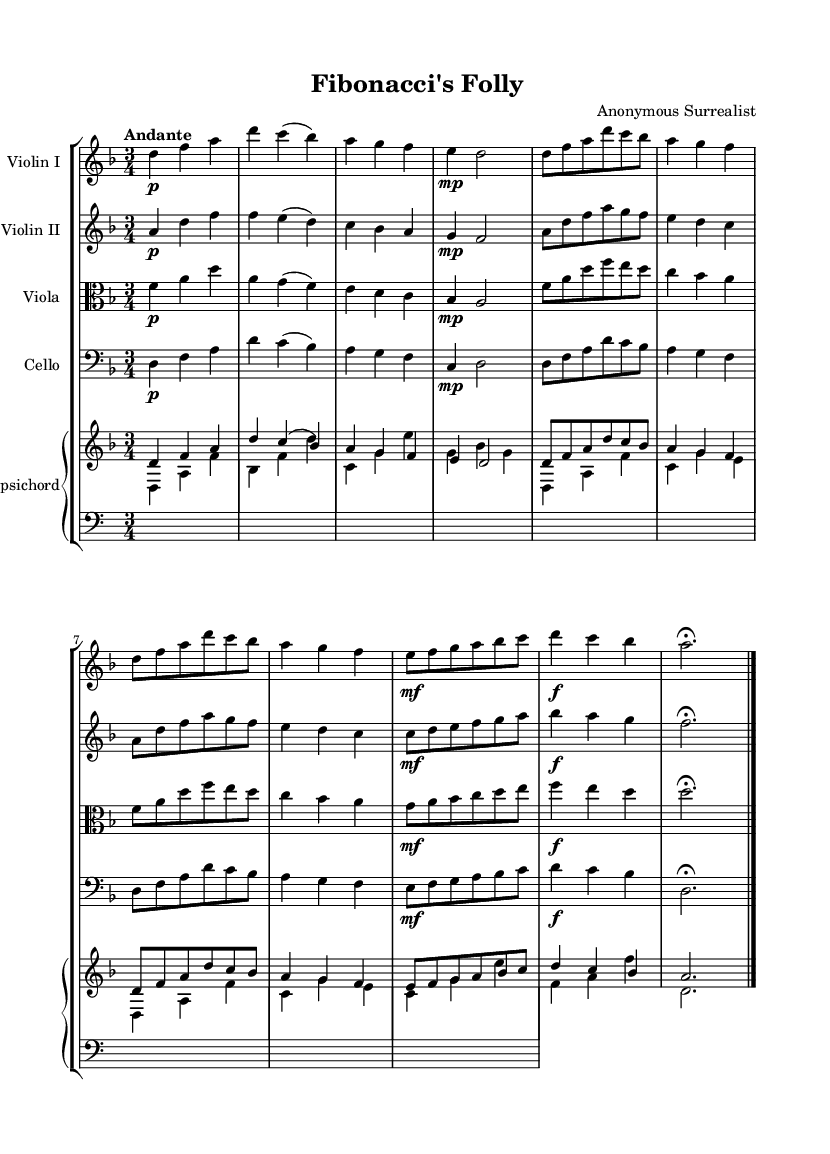What is the key signature of this music? The key signature is indicated at the beginning of the staff, which shows two flats (B-flat and E-flat), confirming that this piece is in the key of D minor.
Answer: D minor What is the time signature of this composition? The time signature appears at the beginning of the music, displayed as a fraction, showing three beats per measure. This signifies that the piece is in triple meter.
Answer: 3/4 What is the tempo marking for this piece? The tempo marking is written above the staff and indicates the desired speed of the music as "Andante", which suggests a moderately slow pace.
Answer: Andante How many measures are in the first violin part? To find the total measures, count each grouping of notes and rests in the first violin part. Upon inspecting, there are a total of 8 measures present in the part.
Answer: 8 What dynamic indication is used for the first violin in the second measure? The dynamic marking for the second measure is displayed as "p," indicating a soft volume intended for that specific measure.
Answer: p Are there any repeated sections in the score? Checking for repeated sections involves identifying any instructions or patterns within the parts that suggest repetition. The code features a repeat sign in several sections that indicates a passage that should be played twice.
Answer: Yes What instruments are involved in this orchestral work? By observing the staff labeled on the score, the involved instruments are listed as Violin I, Violin II, Viola, Cello, and Harpsichord, hence these are the instruments used.
Answer: Violin I, Violin II, Viola, Cello, Harpsichord 